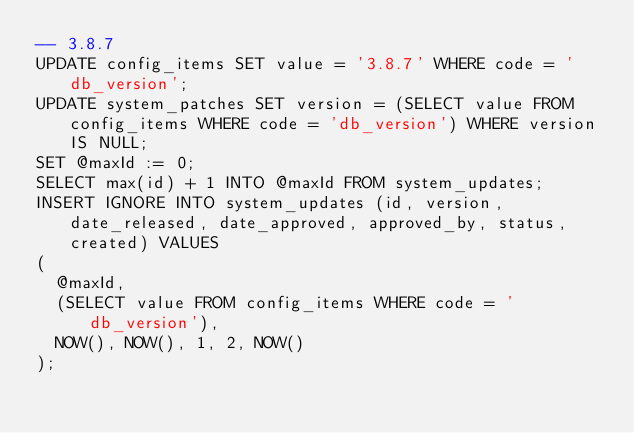Convert code to text. <code><loc_0><loc_0><loc_500><loc_500><_SQL_>-- 3.8.7
UPDATE config_items SET value = '3.8.7' WHERE code = 'db_version';
UPDATE system_patches SET version = (SELECT value FROM config_items WHERE code = 'db_version') WHERE version IS NULL;
SET @maxId := 0;
SELECT max(id) + 1 INTO @maxId FROM system_updates;
INSERT IGNORE INTO system_updates (id, version, date_released, date_approved, approved_by, status, created) VALUES
(
  @maxId,
  (SELECT value FROM config_items WHERE code = 'db_version'),
  NOW(), NOW(), 1, 2, NOW()
);
</code> 